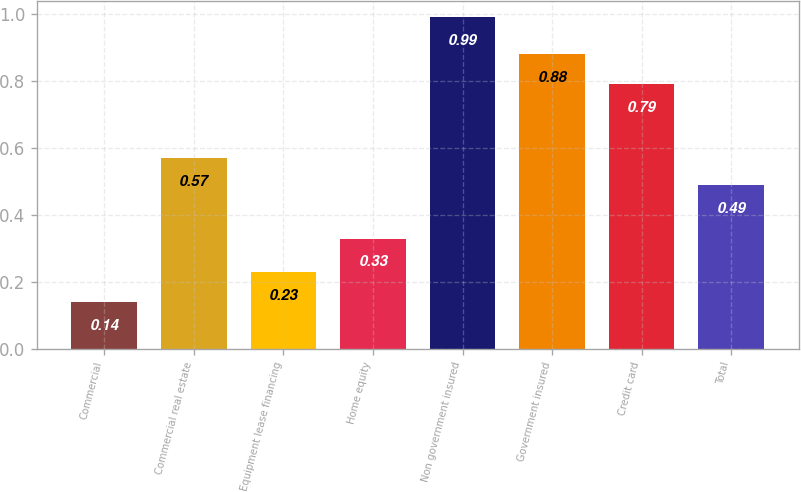<chart> <loc_0><loc_0><loc_500><loc_500><bar_chart><fcel>Commercial<fcel>Commercial real estate<fcel>Equipment lease financing<fcel>Home equity<fcel>Non government insured<fcel>Government insured<fcel>Credit card<fcel>Total<nl><fcel>0.14<fcel>0.57<fcel>0.23<fcel>0.33<fcel>0.99<fcel>0.88<fcel>0.79<fcel>0.49<nl></chart> 